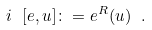Convert formula to latex. <formula><loc_0><loc_0><loc_500><loc_500>i \ [ e , u ] \colon = e ^ { R } ( u ) \ .</formula> 